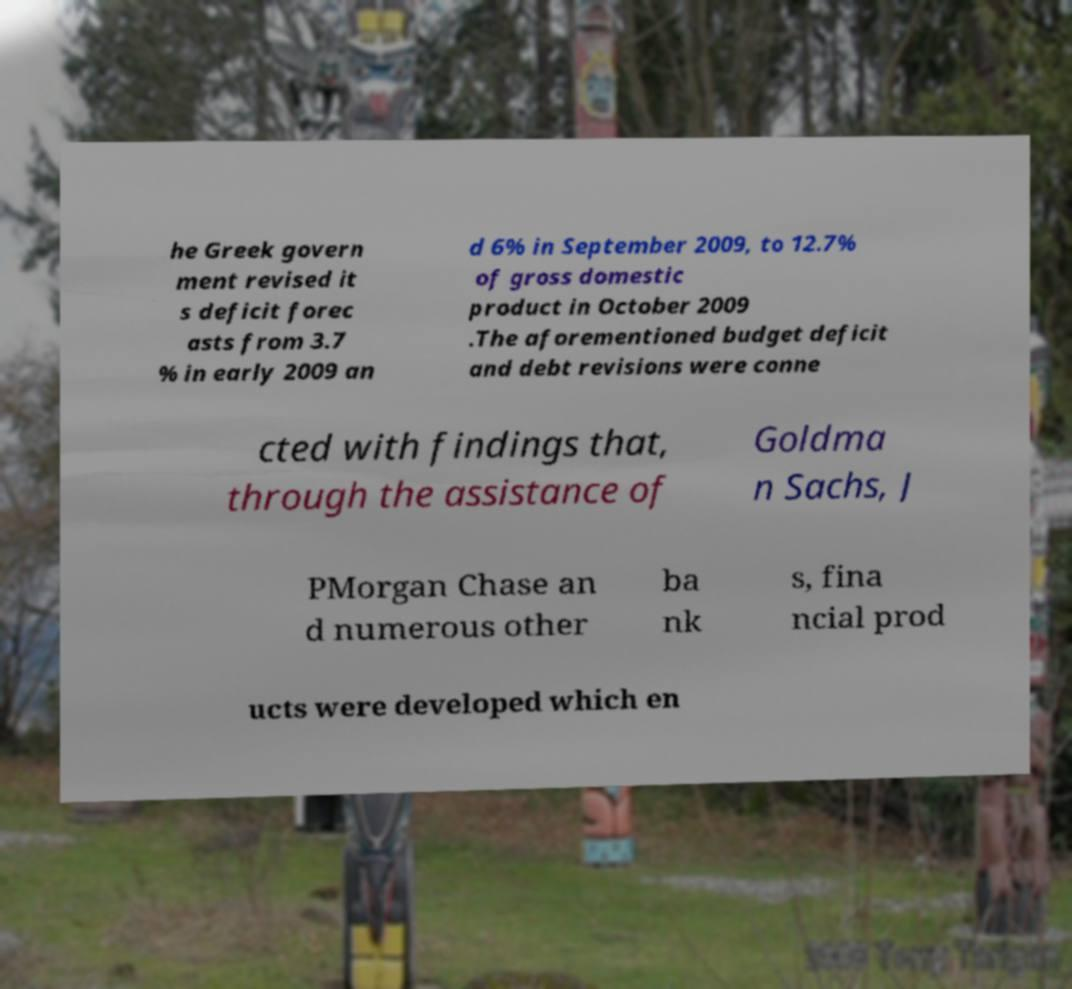Please read and relay the text visible in this image. What does it say? he Greek govern ment revised it s deficit forec asts from 3.7 % in early 2009 an d 6% in September 2009, to 12.7% of gross domestic product in October 2009 .The aforementioned budget deficit and debt revisions were conne cted with findings that, through the assistance of Goldma n Sachs, J PMorgan Chase an d numerous other ba nk s, fina ncial prod ucts were developed which en 